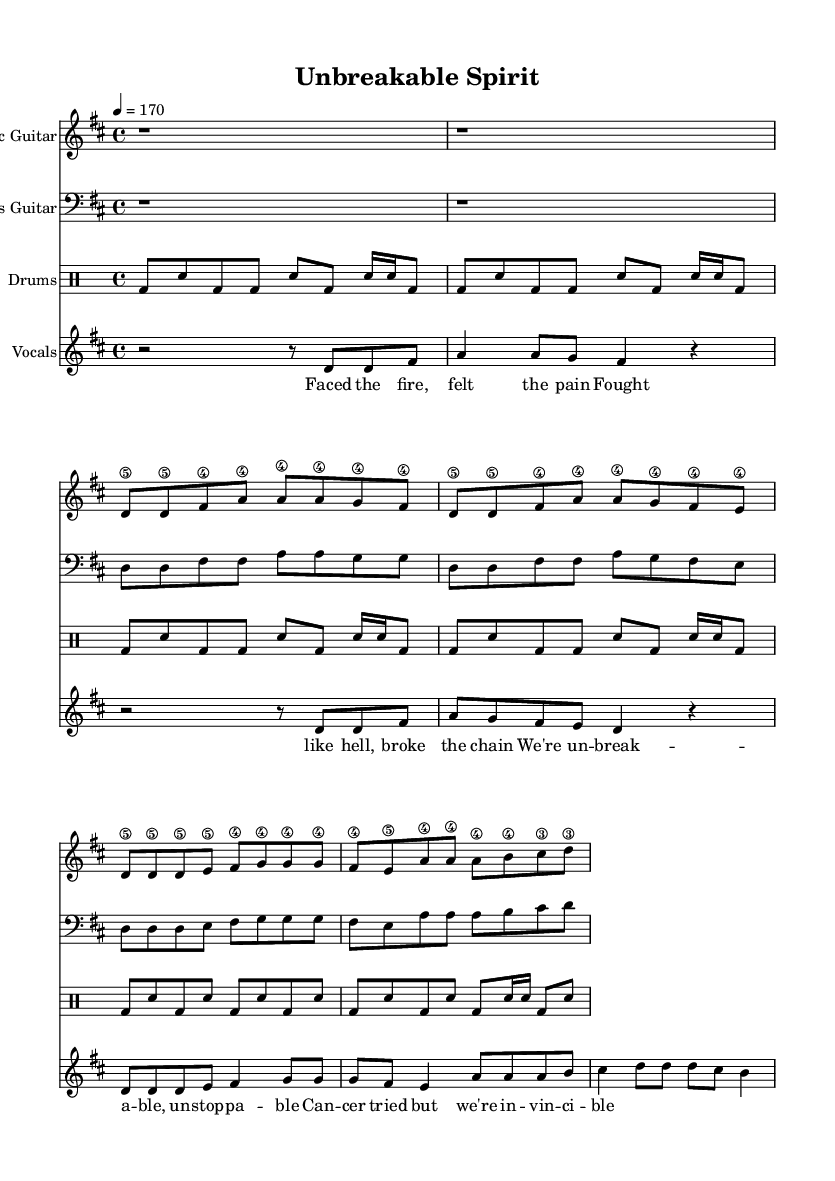What is the key signature of this music? The key signature is indicated by the sharp symbols found in the music. In this case, there can be two sharps (F# and C#) in D major, which is the key signature used throughout.
Answer: D major What is the time signature of this piece? The time signature is found at the beginning of the music score, which indicates how many beats are in each measure. Here, the time signature is 4/4, meaning there are four beats per measure.
Answer: 4/4 What is the tempo marking for this piece? The tempo marking can be found at the top of the sheet music, specifically indicated as "4 = 170," which means the tempo should be set at 170 beats per minute.
Answer: 170 How many measures are there in the chorus? By counting the distinct groupings of notes and rests in the chorus section, you can determine that it consists of a total of 8 measures based on how they are structured and laid out.
Answer: 8 measures What dynamic markings are present, and what do they indicate? Analyzing the music reveals missing explicit dynamic markings, which are typically annotated to indicate volume. The absence suggests that performers are encouraged to expressively interpret volume but are held to punk's naturally loud and aggressive dynamics.
Answer: None Which instruments are included in this arrangement? By examining the score at the top of each staff and identifying the associated parts, we see Electric Guitar, Bass Guitar, Drums, and Vocals are all present in this punk arrangement.
Answer: Electric Guitar, Bass Guitar, Drums, Vocals What themes are represented in the lyrics of this song? The lyrics express themes of resilience and triumph over adversity, particularly in fighting cancer, which aligns with the upbeat and assertive style typical of punk music.
Answer: Resilience and triumph 